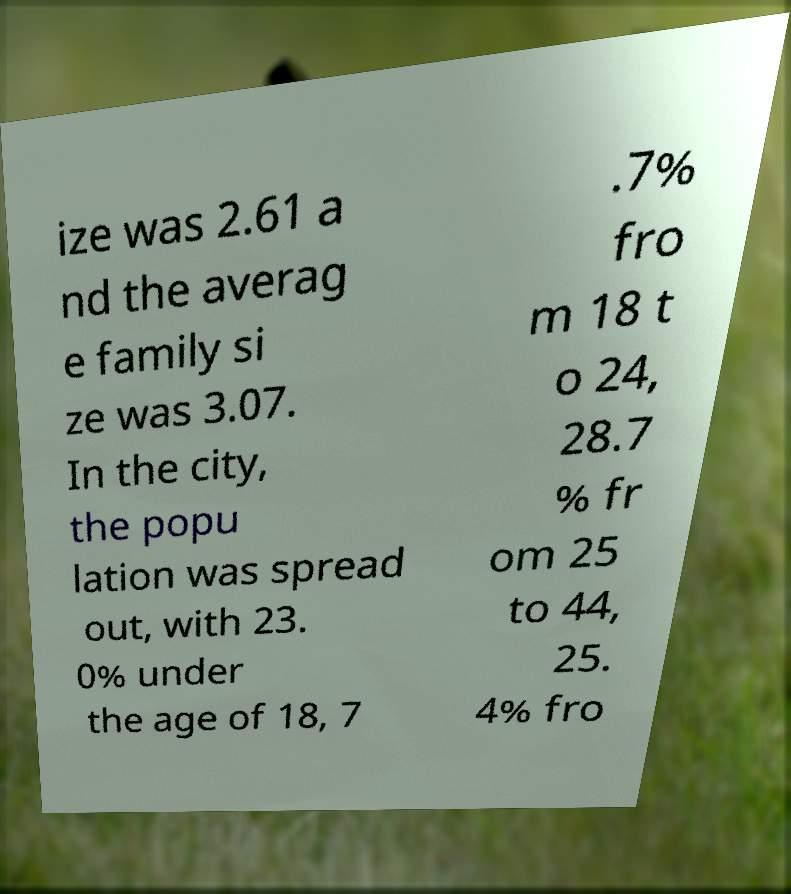Can you accurately transcribe the text from the provided image for me? ize was 2.61 a nd the averag e family si ze was 3.07. In the city, the popu lation was spread out, with 23. 0% under the age of 18, 7 .7% fro m 18 t o 24, 28.7 % fr om 25 to 44, 25. 4% fro 